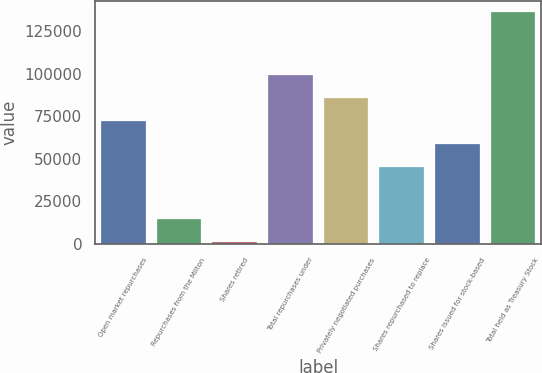Convert chart to OTSL. <chart><loc_0><loc_0><loc_500><loc_500><bar_chart><fcel>Open market repurchases<fcel>Repurchases from the Milton<fcel>Shares retired<fcel>Total repurchases under<fcel>Privately negotiated purchases<fcel>Shares repurchased to replace<fcel>Shares issued for stock-based<fcel>Total held as Treasury Stock<nl><fcel>71985.2<fcel>14551.1<fcel>1056<fcel>98975.4<fcel>85480.3<fcel>44995<fcel>58490.1<fcel>136007<nl></chart> 